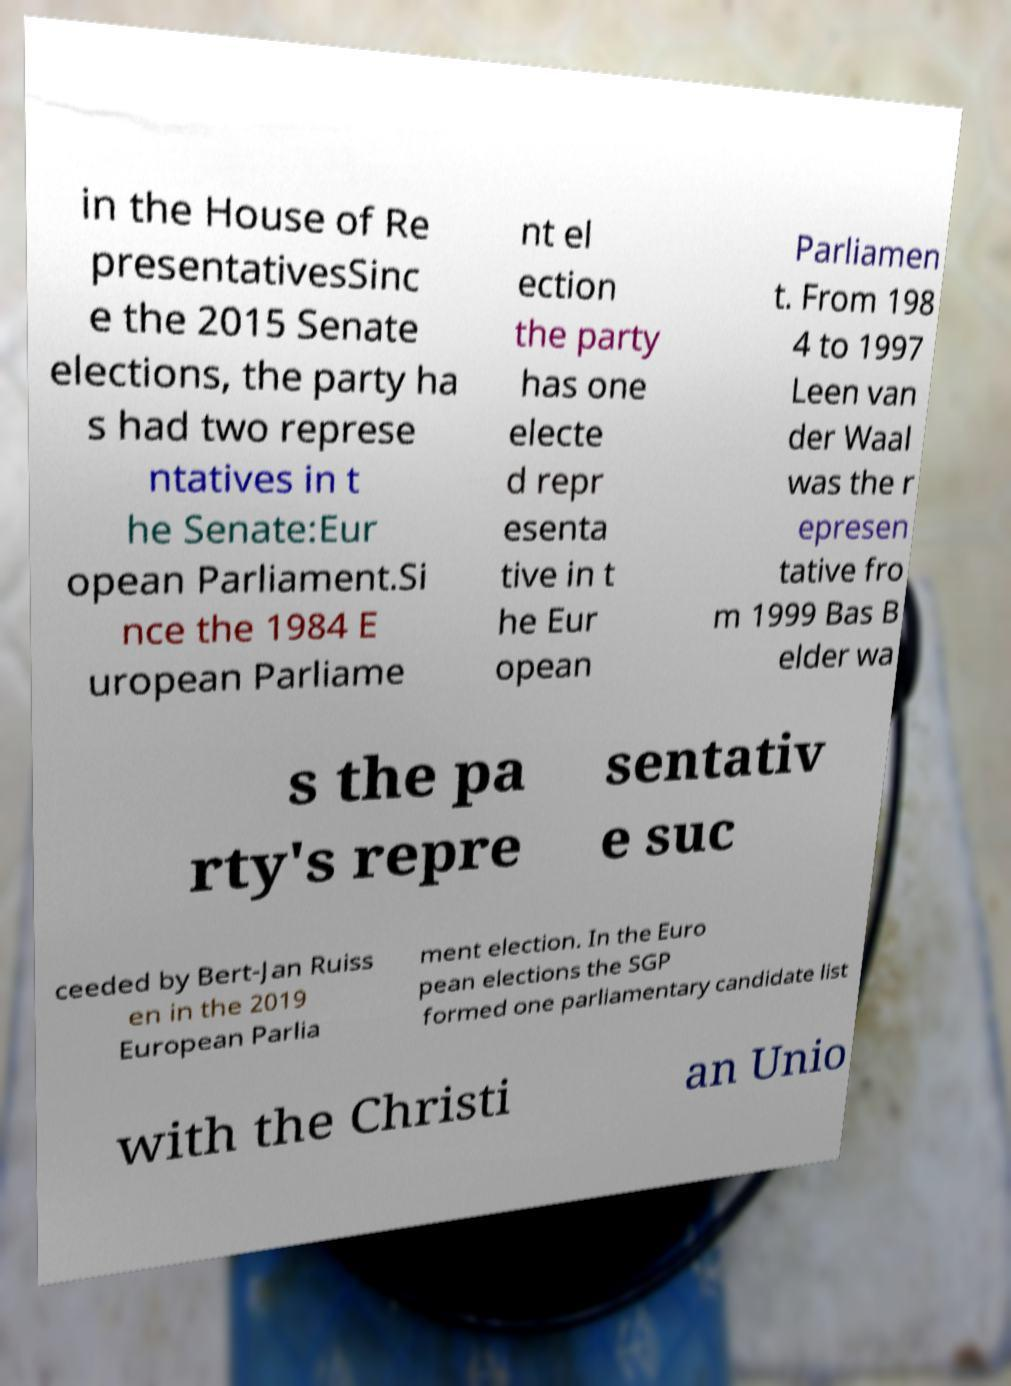Can you read and provide the text displayed in the image?This photo seems to have some interesting text. Can you extract and type it out for me? in the House of Re presentativesSinc e the 2015 Senate elections, the party ha s had two represe ntatives in t he Senate:Eur opean Parliament.Si nce the 1984 E uropean Parliame nt el ection the party has one electe d repr esenta tive in t he Eur opean Parliamen t. From 198 4 to 1997 Leen van der Waal was the r epresen tative fro m 1999 Bas B elder wa s the pa rty's repre sentativ e suc ceeded by Bert-Jan Ruiss en in the 2019 European Parlia ment election. In the Euro pean elections the SGP formed one parliamentary candidate list with the Christi an Unio 